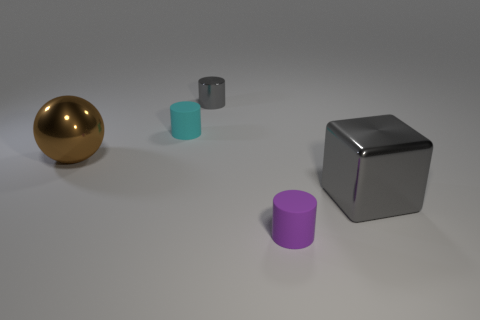Add 1 gray blocks. How many objects exist? 6 Subtract all cubes. How many objects are left? 4 Subtract 0 cyan balls. How many objects are left? 5 Subtract all metal blocks. Subtract all big gray blocks. How many objects are left? 3 Add 1 big metal blocks. How many big metal blocks are left? 2 Add 1 big things. How many big things exist? 3 